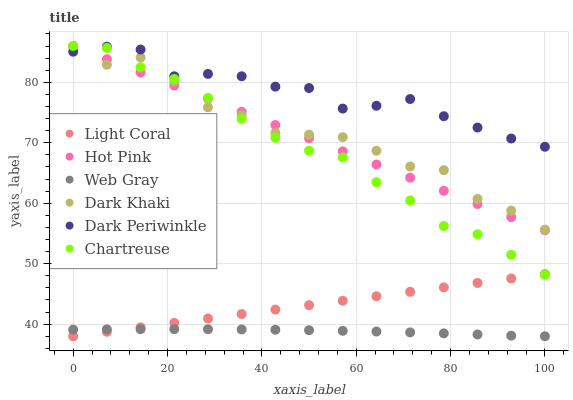Does Web Gray have the minimum area under the curve?
Answer yes or no. Yes. Does Dark Periwinkle have the maximum area under the curve?
Answer yes or no. Yes. Does Hot Pink have the minimum area under the curve?
Answer yes or no. No. Does Hot Pink have the maximum area under the curve?
Answer yes or no. No. Is Light Coral the smoothest?
Answer yes or no. Yes. Is Dark Khaki the roughest?
Answer yes or no. Yes. Is Web Gray the smoothest?
Answer yes or no. No. Is Web Gray the roughest?
Answer yes or no. No. Does Web Gray have the lowest value?
Answer yes or no. Yes. Does Hot Pink have the lowest value?
Answer yes or no. No. Does Chartreuse have the highest value?
Answer yes or no. Yes. Does Web Gray have the highest value?
Answer yes or no. No. Is Light Coral less than Hot Pink?
Answer yes or no. Yes. Is Dark Periwinkle greater than Web Gray?
Answer yes or no. Yes. Does Chartreuse intersect Light Coral?
Answer yes or no. Yes. Is Chartreuse less than Light Coral?
Answer yes or no. No. Is Chartreuse greater than Light Coral?
Answer yes or no. No. Does Light Coral intersect Hot Pink?
Answer yes or no. No. 